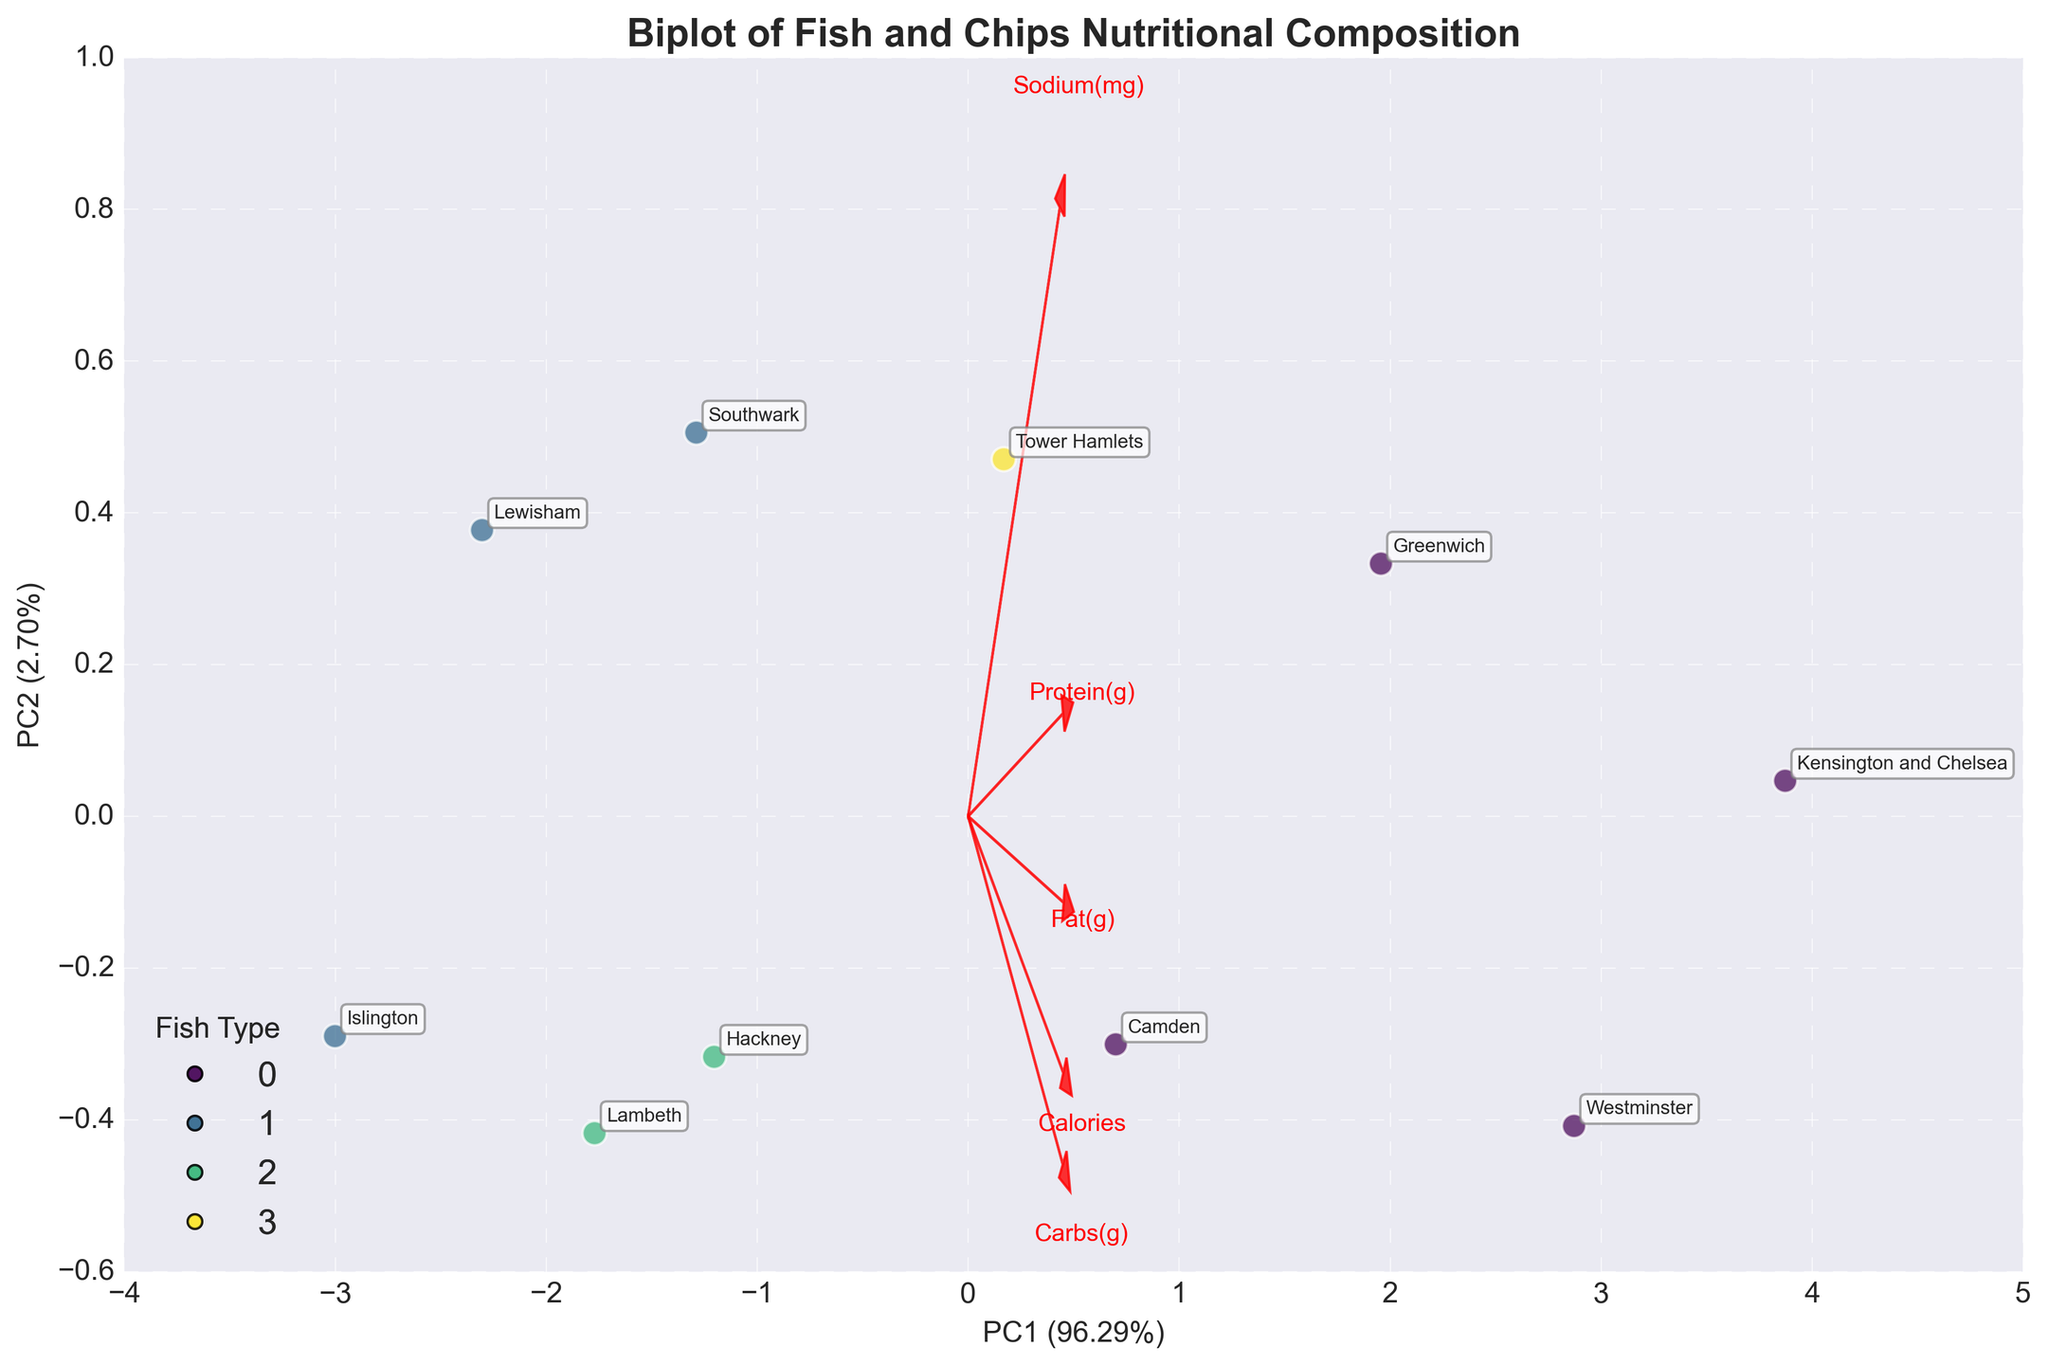What is the title of the biplot? The title is directly stated at the top of the biplot.
Answer: Biplot of Fish and Chips Nutritional Composition How many boroughs are represented in the biplot? Each borough is represented by a labeled data point in the plot. Count each label to find the total number.
Answer: 10 Which fish type is most represented in the biplot? By looking at the legend and the data points, check which color appears most frequently.
Answer: Cod What percent variance is explained by the first principal component (PC1)? Look at the x-axis label where the percentage of variance explained by PC1 is given.
Answer: Approximately 74% Which borough has the highest sodium content based on its position on the biplot? Check the direction and length of the sodium vector arrow, then identify the point farthest along this direction.
Answer: Kensington and Chelsea How do the nutritional compositions of Haddock and Cod compare in the biplot? Look at where the data points for Haddock and Cod are clustered and identify common patterns or differences, such as proximity to certain feature vectors.
Answer: Cod points tend to be higher in Calories, Protein, Fat, Carbs, and Sodium Which feature contributes most to the second principal component (PC2)? Check which feature vector is longest and most aligned in the vertical direction (associated with PC2).
Answer: Fat Which borough is highest in protein content and what fish type is used there? Look at the position along the vector representing Protein to determine the highest point and then check its label.
Answer: Kensington and Chelsea, Cod Calculate the mean calorie count for the represented dishes in the biplot. Sum up the calorie counts for all boroughs (850 + 780 + 820 + 890 + 800 + 830 + 810 + 870 + 790 + 900) and divide by the number of boroughs (10).
Answer: 834 